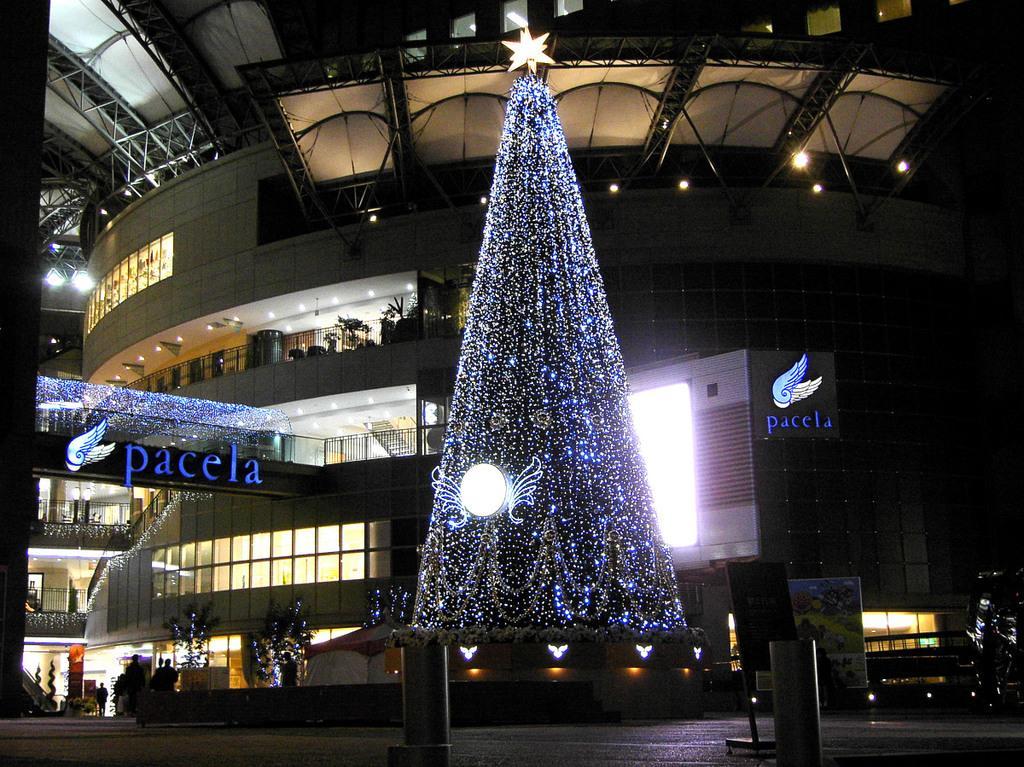Could you give a brief overview of what you see in this image? In this picture there is a building. In the foreground there is a Christmas tree and there are lights on the tree and there is text on the building. At the bottom there are group of people walking and there are objects. On the left side of the image there is an escalator and there are plants behind the railing. At the top there are lights. 